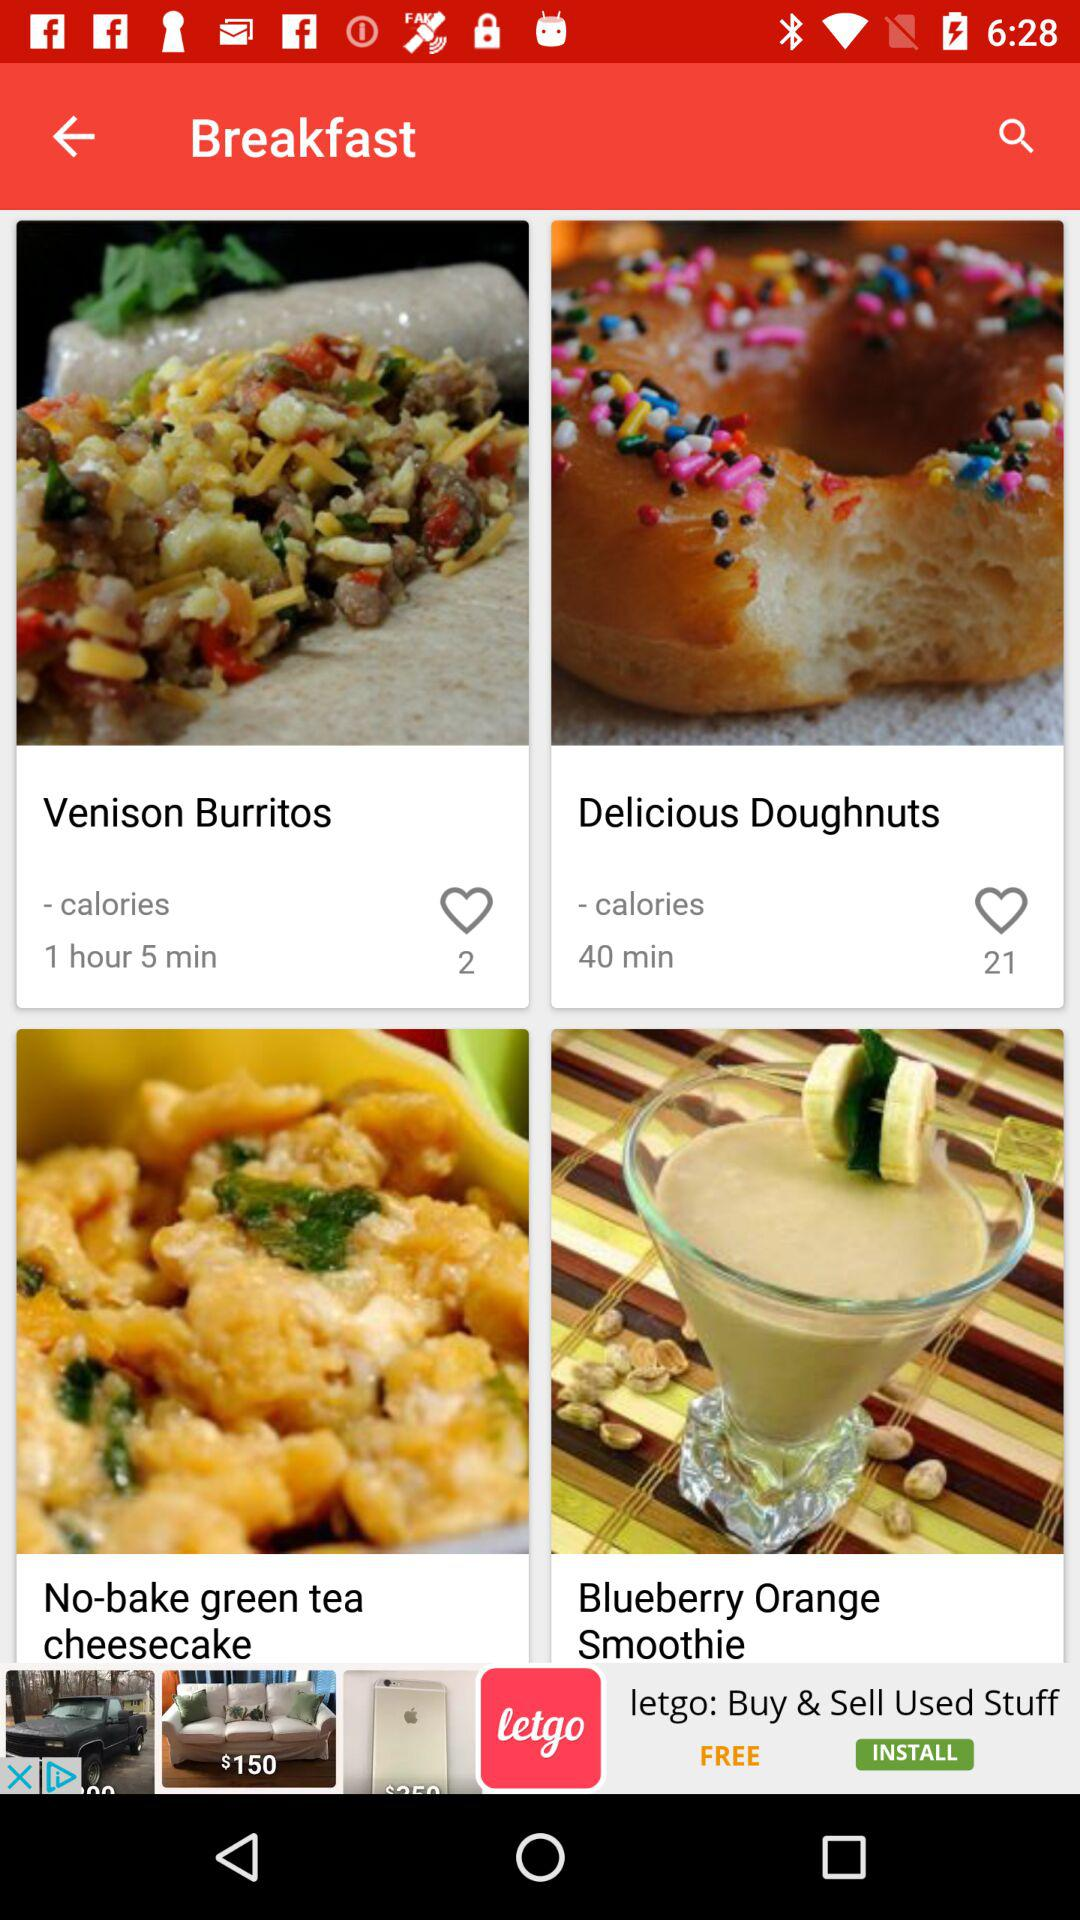What is the preparation time for Venison Burritos? The preparation time for Venison Burritos is 1 hour 5 minutes. 